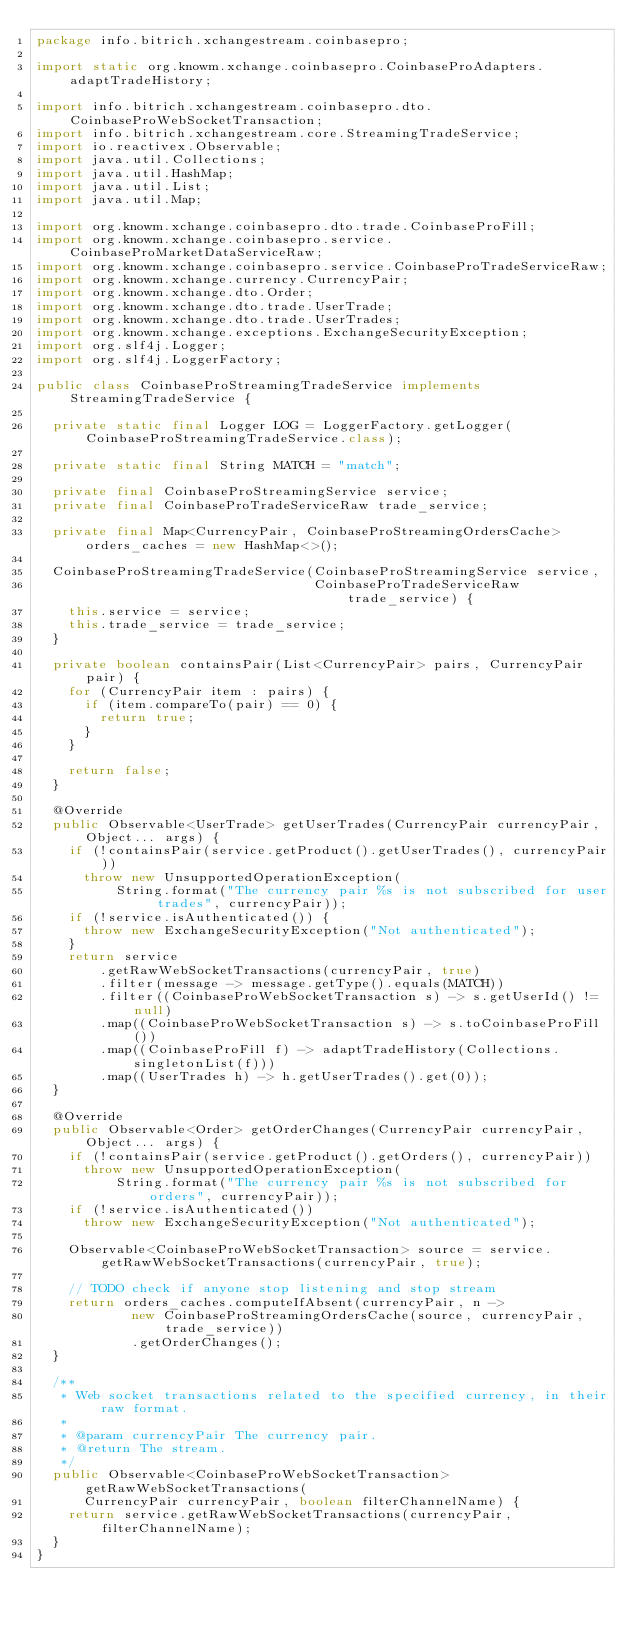<code> <loc_0><loc_0><loc_500><loc_500><_Java_>package info.bitrich.xchangestream.coinbasepro;

import static org.knowm.xchange.coinbasepro.CoinbaseProAdapters.adaptTradeHistory;

import info.bitrich.xchangestream.coinbasepro.dto.CoinbaseProWebSocketTransaction;
import info.bitrich.xchangestream.core.StreamingTradeService;
import io.reactivex.Observable;
import java.util.Collections;
import java.util.HashMap;
import java.util.List;
import java.util.Map;

import org.knowm.xchange.coinbasepro.dto.trade.CoinbaseProFill;
import org.knowm.xchange.coinbasepro.service.CoinbaseProMarketDataServiceRaw;
import org.knowm.xchange.coinbasepro.service.CoinbaseProTradeServiceRaw;
import org.knowm.xchange.currency.CurrencyPair;
import org.knowm.xchange.dto.Order;
import org.knowm.xchange.dto.trade.UserTrade;
import org.knowm.xchange.dto.trade.UserTrades;
import org.knowm.xchange.exceptions.ExchangeSecurityException;
import org.slf4j.Logger;
import org.slf4j.LoggerFactory;

public class CoinbaseProStreamingTradeService implements StreamingTradeService {

  private static final Logger LOG = LoggerFactory.getLogger(CoinbaseProStreamingTradeService.class);

  private static final String MATCH = "match";

  private final CoinbaseProStreamingService service;
  private final CoinbaseProTradeServiceRaw trade_service;
  
  private final Map<CurrencyPair, CoinbaseProStreamingOrdersCache> orders_caches = new HashMap<>();

  CoinbaseProStreamingTradeService(CoinbaseProStreamingService service,
                                   CoinbaseProTradeServiceRaw trade_service) {
    this.service = service;
    this.trade_service = trade_service;
  }

  private boolean containsPair(List<CurrencyPair> pairs, CurrencyPair pair) {
    for (CurrencyPair item : pairs) {
      if (item.compareTo(pair) == 0) {
        return true;
      }
    }

    return false;
  }

  @Override
  public Observable<UserTrade> getUserTrades(CurrencyPair currencyPair, Object... args) {
    if (!containsPair(service.getProduct().getUserTrades(), currencyPair))
      throw new UnsupportedOperationException(
          String.format("The currency pair %s is not subscribed for user trades", currencyPair));
    if (!service.isAuthenticated()) {
      throw new ExchangeSecurityException("Not authenticated");
    }
    return service
        .getRawWebSocketTransactions(currencyPair, true)
        .filter(message -> message.getType().equals(MATCH))
        .filter((CoinbaseProWebSocketTransaction s) -> s.getUserId() != null)
        .map((CoinbaseProWebSocketTransaction s) -> s.toCoinbaseProFill())
        .map((CoinbaseProFill f) -> adaptTradeHistory(Collections.singletonList(f)))
        .map((UserTrades h) -> h.getUserTrades().get(0));
  }

  @Override
  public Observable<Order> getOrderChanges(CurrencyPair currencyPair, Object... args) {
    if (!containsPair(service.getProduct().getOrders(), currencyPair))
      throw new UnsupportedOperationException(
          String.format("The currency pair %s is not subscribed for orders", currencyPair));
    if (!service.isAuthenticated())
      throw new ExchangeSecurityException("Not authenticated");
  
    Observable<CoinbaseProWebSocketTransaction> source = service.getRawWebSocketTransactions(currencyPair, true);
    
    // TODO check if anyone stop listening and stop stream
    return orders_caches.computeIfAbsent(currencyPair, n ->
            new CoinbaseProStreamingOrdersCache(source, currencyPair, trade_service))
            .getOrderChanges();
  }

  /**
   * Web socket transactions related to the specified currency, in their raw format.
   *
   * @param currencyPair The currency pair.
   * @return The stream.
   */
  public Observable<CoinbaseProWebSocketTransaction> getRawWebSocketTransactions(
      CurrencyPair currencyPair, boolean filterChannelName) {
    return service.getRawWebSocketTransactions(currencyPair, filterChannelName);
  }
}
</code> 